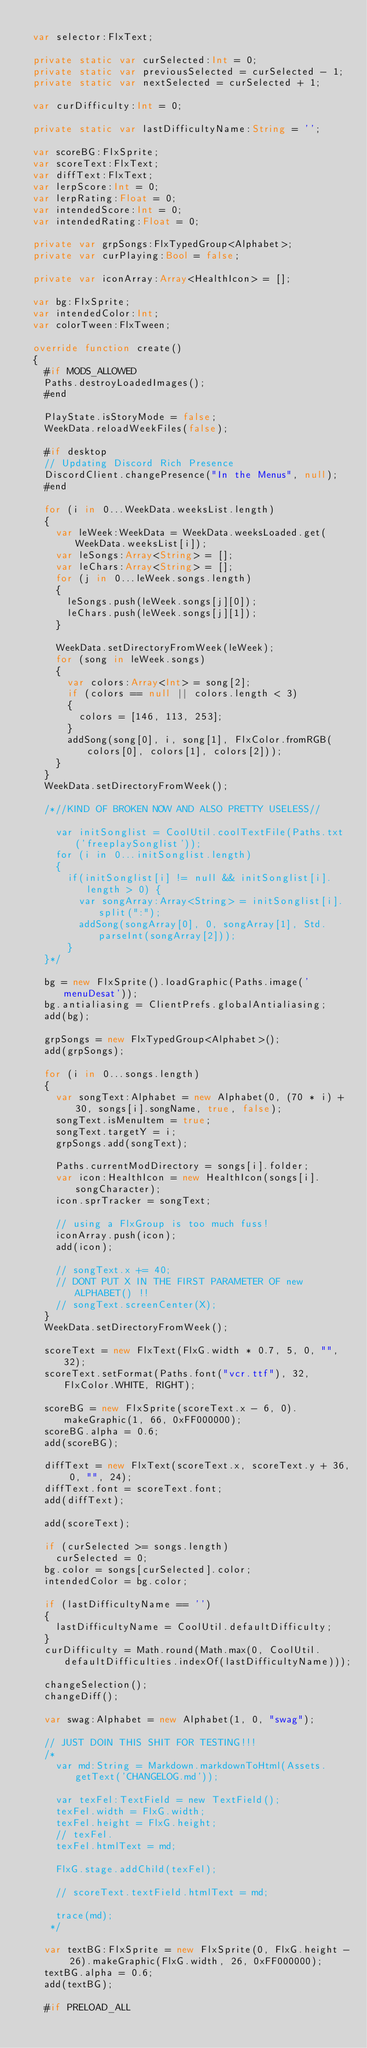<code> <loc_0><loc_0><loc_500><loc_500><_Haxe_>
	var selector:FlxText;

	private static var curSelected:Int = 0;
	private static var previousSelected = curSelected - 1;
	private static var nextSelected = curSelected + 1;

	var curDifficulty:Int = 0;

	private static var lastDifficultyName:String = '';

	var scoreBG:FlxSprite;
	var scoreText:FlxText;
	var diffText:FlxText;
	var lerpScore:Int = 0;
	var lerpRating:Float = 0;
	var intendedScore:Int = 0;
	var intendedRating:Float = 0;

	private var grpSongs:FlxTypedGroup<Alphabet>;
	private var curPlaying:Bool = false;

	private var iconArray:Array<HealthIcon> = [];

	var bg:FlxSprite;
	var intendedColor:Int;
	var colorTween:FlxTween;

	override function create()
	{
		#if MODS_ALLOWED
		Paths.destroyLoadedImages();
		#end

		PlayState.isStoryMode = false;
		WeekData.reloadWeekFiles(false);

		#if desktop
		// Updating Discord Rich Presence
		DiscordClient.changePresence("In the Menus", null);
		#end

		for (i in 0...WeekData.weeksList.length)
		{
			var leWeek:WeekData = WeekData.weeksLoaded.get(WeekData.weeksList[i]);
			var leSongs:Array<String> = [];
			var leChars:Array<String> = [];
			for (j in 0...leWeek.songs.length)
			{
				leSongs.push(leWeek.songs[j][0]);
				leChars.push(leWeek.songs[j][1]);
			}

			WeekData.setDirectoryFromWeek(leWeek);
			for (song in leWeek.songs)
			{
				var colors:Array<Int> = song[2];
				if (colors == null || colors.length < 3)
				{
					colors = [146, 113, 253];
				}
				addSong(song[0], i, song[1], FlxColor.fromRGB(colors[0], colors[1], colors[2]));
			}
		}
		WeekData.setDirectoryFromWeek();

		/*//KIND OF BROKEN NOW AND ALSO PRETTY USELESS//

			var initSonglist = CoolUtil.coolTextFile(Paths.txt('freeplaySonglist'));
			for (i in 0...initSonglist.length)
			{
				if(initSonglist[i] != null && initSonglist[i].length > 0) {
					var songArray:Array<String> = initSonglist[i].split(":");
					addSong(songArray[0], 0, songArray[1], Std.parseInt(songArray[2]));
				}
		}*/

		bg = new FlxSprite().loadGraphic(Paths.image('menuDesat'));
		bg.antialiasing = ClientPrefs.globalAntialiasing;
		add(bg);

		grpSongs = new FlxTypedGroup<Alphabet>();
		add(grpSongs);

		for (i in 0...songs.length)
		{
			var songText:Alphabet = new Alphabet(0, (70 * i) + 30, songs[i].songName, true, false);
			songText.isMenuItem = true;
			songText.targetY = i;
			grpSongs.add(songText);

			Paths.currentModDirectory = songs[i].folder;
			var icon:HealthIcon = new HealthIcon(songs[i].songCharacter);
			icon.sprTracker = songText;

			// using a FlxGroup is too much fuss!
			iconArray.push(icon);
			add(icon);

			// songText.x += 40;
			// DONT PUT X IN THE FIRST PARAMETER OF new ALPHABET() !!
			// songText.screenCenter(X);
		}
		WeekData.setDirectoryFromWeek();

		scoreText = new FlxText(FlxG.width * 0.7, 5, 0, "", 32);
		scoreText.setFormat(Paths.font("vcr.ttf"), 32, FlxColor.WHITE, RIGHT);

		scoreBG = new FlxSprite(scoreText.x - 6, 0).makeGraphic(1, 66, 0xFF000000);
		scoreBG.alpha = 0.6;
		add(scoreBG);

		diffText = new FlxText(scoreText.x, scoreText.y + 36, 0, "", 24);
		diffText.font = scoreText.font;
		add(diffText);

		add(scoreText);

		if (curSelected >= songs.length)
			curSelected = 0;
		bg.color = songs[curSelected].color;
		intendedColor = bg.color;

		if (lastDifficultyName == '')
		{
			lastDifficultyName = CoolUtil.defaultDifficulty;
		}
		curDifficulty = Math.round(Math.max(0, CoolUtil.defaultDifficulties.indexOf(lastDifficultyName)));

		changeSelection();
		changeDiff();

		var swag:Alphabet = new Alphabet(1, 0, "swag");

		// JUST DOIN THIS SHIT FOR TESTING!!!
		/* 
			var md:String = Markdown.markdownToHtml(Assets.getText('CHANGELOG.md'));

			var texFel:TextField = new TextField();
			texFel.width = FlxG.width;
			texFel.height = FlxG.height;
			// texFel.
			texFel.htmlText = md;

			FlxG.stage.addChild(texFel);

			// scoreText.textField.htmlText = md;

			trace(md);
		 */

		var textBG:FlxSprite = new FlxSprite(0, FlxG.height - 26).makeGraphic(FlxG.width, 26, 0xFF000000);
		textBG.alpha = 0.6;
		add(textBG);

		#if PRELOAD_ALL</code> 